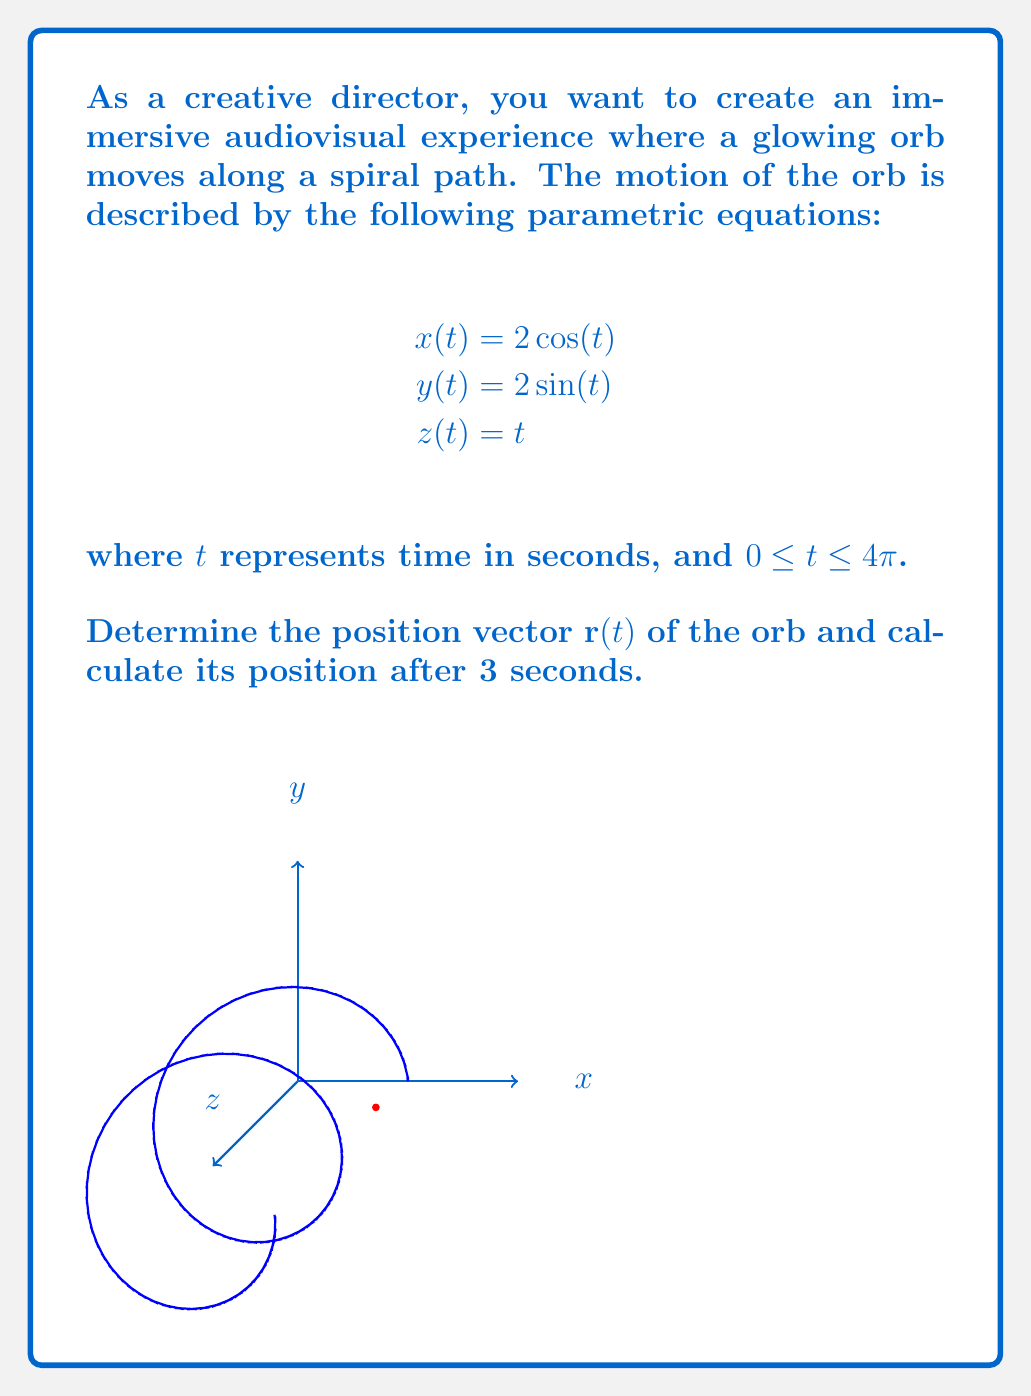What is the answer to this math problem? To solve this problem, we'll follow these steps:

1) First, we need to express the position vector $\mathbf{r}(t)$ using the given parametric equations:

   $$\mathbf{r}(t) = x(t)\mathbf{i} + y(t)\mathbf{j} + z(t)\mathbf{k}$$
   $$\mathbf{r}(t) = 2\cos(t)\mathbf{i} + 2\sin(t)\mathbf{j} + t\mathbf{k}$$

2) Now, to find the position after 3 seconds, we need to evaluate $\mathbf{r}(3)$:

   $$\mathbf{r}(3) = 2\cos(3)\mathbf{i} + 2\sin(3)\mathbf{j} + 3\mathbf{k}$$

3) Let's calculate the scalar values:
   
   $\cos(3) \approx -0.9900$
   $\sin(3) \approx 0.1411$

4) Substituting these values:

   $$\mathbf{r}(3) \approx -1.9800\mathbf{i} + 0.2822\mathbf{j} + 3\mathbf{k}$$

Therefore, after 3 seconds, the orb will be at the position approximately (-1.9800, 0.2822, 3) in the 3D space.
Answer: $\mathbf{r}(t) = 2\cos(t)\mathbf{i} + 2\sin(t)\mathbf{j} + t\mathbf{k}$; $\mathbf{r}(3) \approx -1.9800\mathbf{i} + 0.2822\mathbf{j} + 3\mathbf{k}$ 